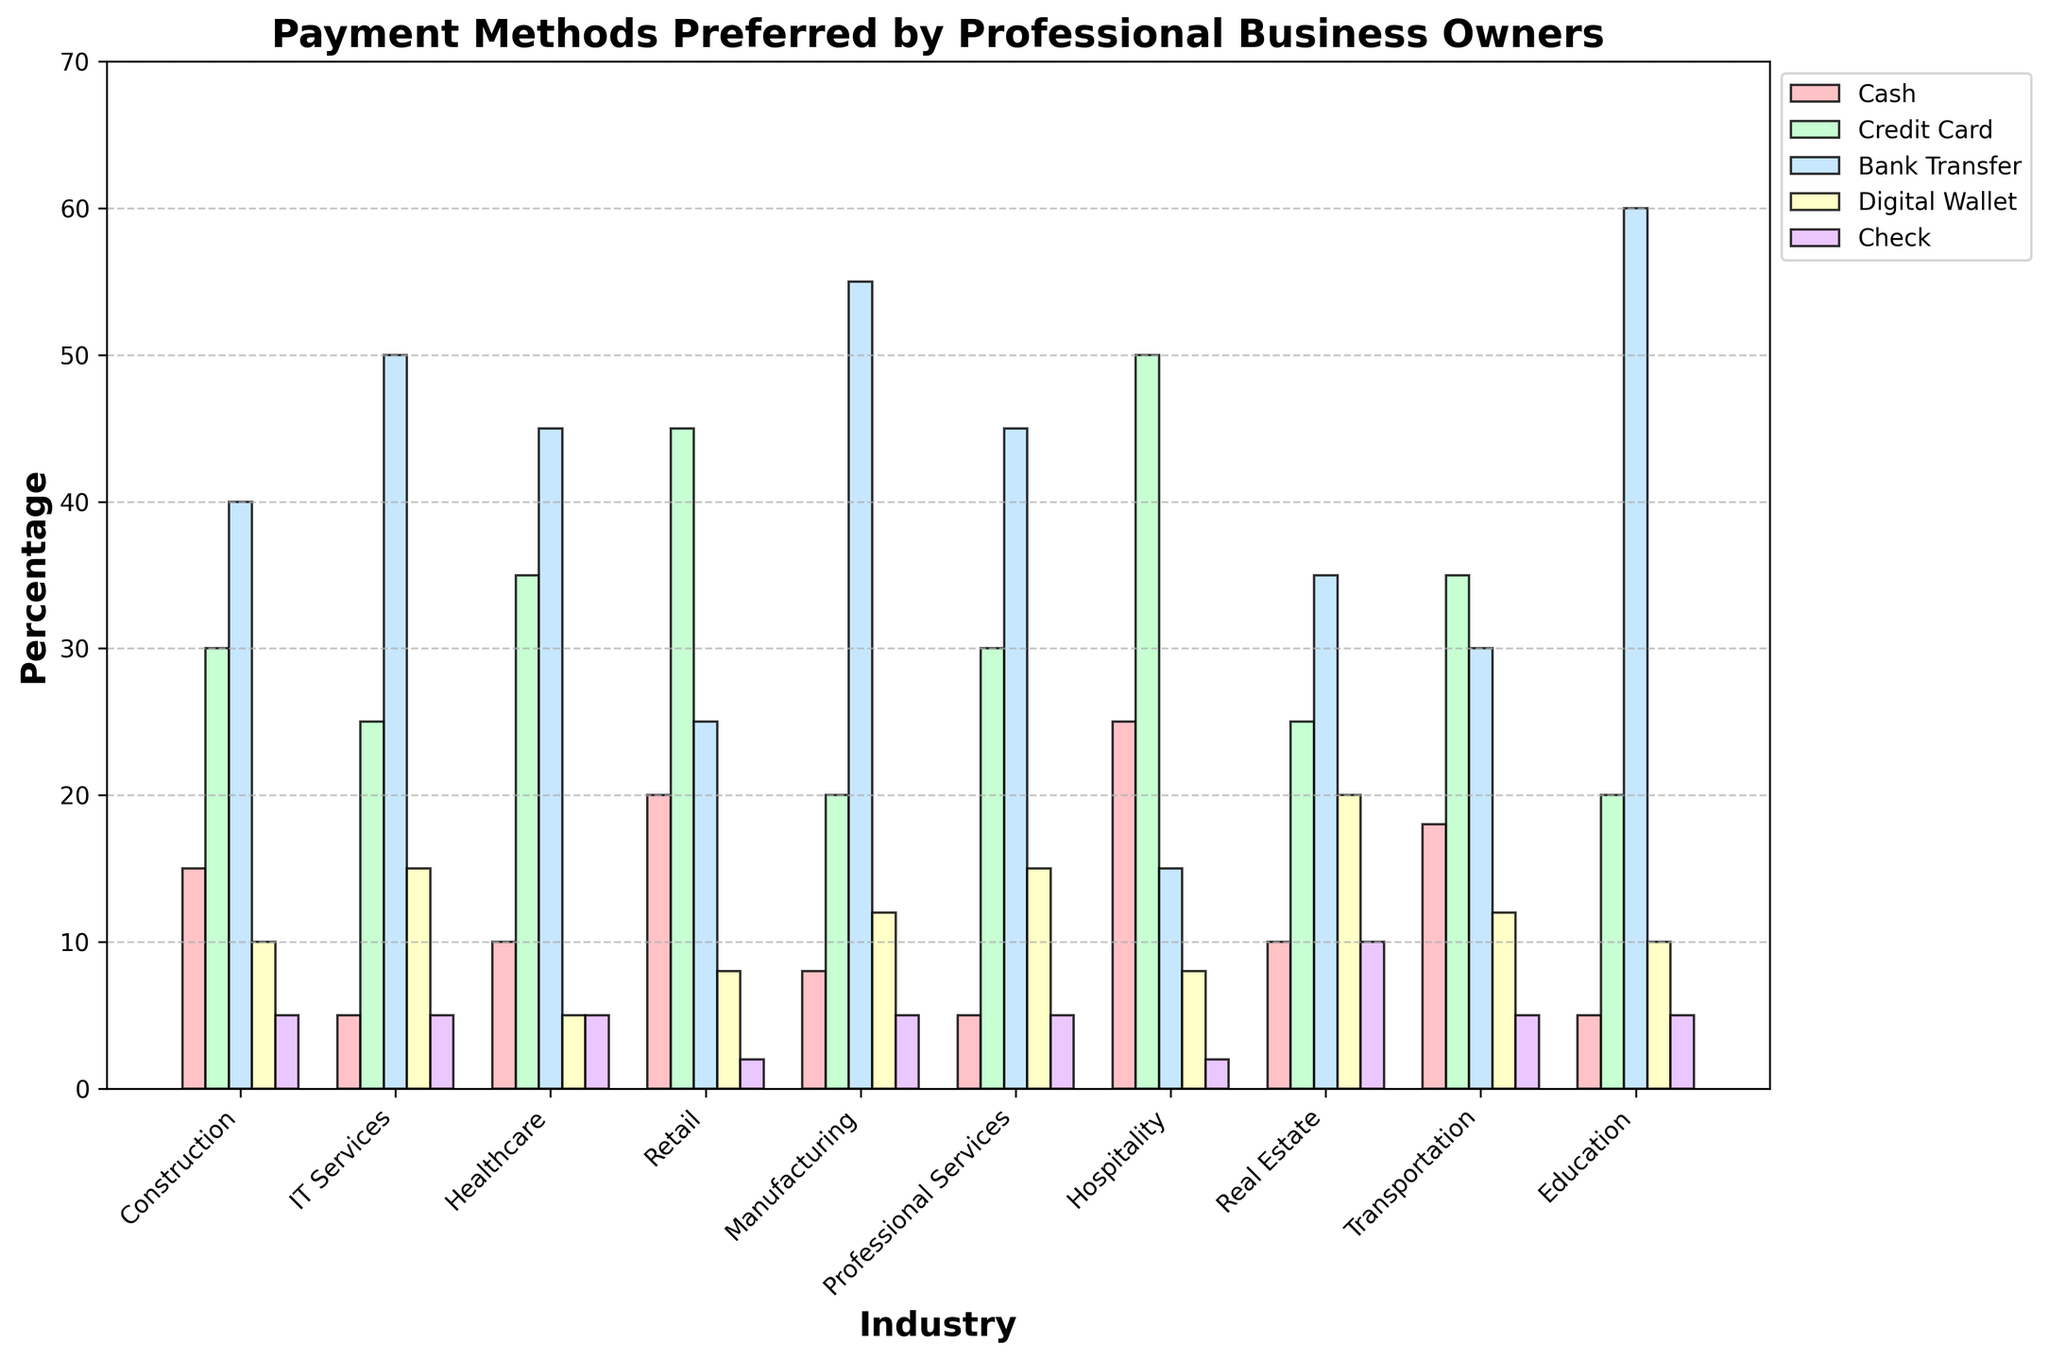Which industry prefers Digital Wallets the most? By comparing the heights of the blue bars that represent Digital Wallets across all industries, we can see that the Real Estate industry has the highest percentage at 20%.
Answer: Real Estate In which industry is Bank Transfer the preferred payment method by more than half of the business owners? By looking at the purple bars that represent Bank Transfer, only the Education industry has a height over 50%, indicating more than half of the business owners prefer this method.
Answer: Education How many payment methods have a higher percentage in Retail than in IT Services? By examining the heights of the bars for each payment method in the Retail and IT Services industries:
- Cash: 20% (Retail) > 5% (IT Services)
- Credit Card: 45% (Retail) > 25% (IT Services)
- Bank Transfer: 25% (Retail) < 50% (IT Services)
- Digital Wallet: 8% (Retail) < 15% (IT Services)
- Check: 2% (Retail) < 5% (IT Services)
Thus, there are 2 payment methods (Cash and Credit Card) with a higher percentage in Retail.
Answer: 2 Is the percentage of professional business owners in Healthcare preferring Credit Card payment greater than those in Transportation preferring the same method? By looking at the green bars representing Credit Card payment, Healthcare has a percentage of 35%, while Transportation has a percentage of 35%. Since they are equal, Healthcare is not greater than Transportation.
Answer: No Which industry has the lowest preference for Check payments? By comparing the heights of the yellow bars representing Check payments across all industries, Retail has the shortest bar at 2%.
Answer: Retail Among the payment methods in Professional Services, which method is preferred by the least percentage of business owners? By comparing the bars within the Professional Services category, Cash has the shortest bar at 5%, indicating it is preferred by the least percentage of business owners.
Answer: Cash Summing up all the percentages for Digital Wallet payments, which two industries contribute the most using this method? By examining the bars for Digital Wallet:
- Construction: 10%
- IT Services: 15%
- Healthcare: 5%
- Retail: 8%
- Manufacturing: 12%
- Professional Services: 15%
- Hospitality: 8%
- Real Estate: 20%
- Transportation: 12%
- Education: 10%
The highest two bars are Real Estate (20%) and IT Services (15%) for a total of 35%.
Answer: Real Estate and IT Services Comparing Transportation and Hospitality, which industry has a higher preference for Bank Transfer, and by how much? By examining the purple bars:
- Transportation: 30%
- Hospitality: 15%
The difference is 30% - 15% = 15%, so Transportation has a higher preference by 15%.
Answer: Transportation, by 15% What color represents the Digital Wallet payments in the chart? By noting the color assigned to Digital Wallet payments, they are represented by blue bars.
Answer: Blue 